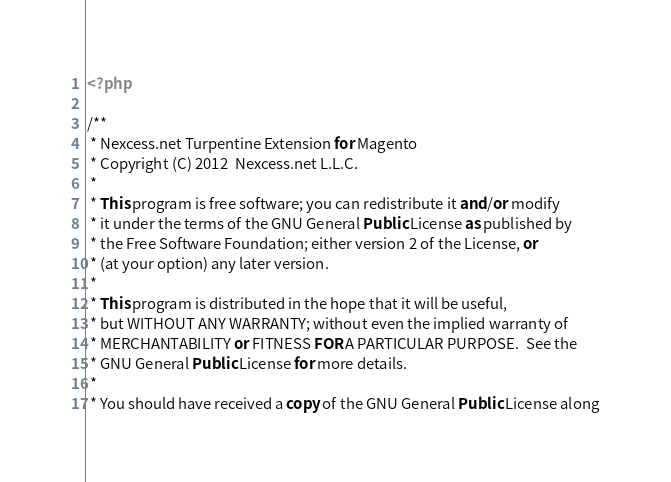<code> <loc_0><loc_0><loc_500><loc_500><_PHP_><?php

/**
 * Nexcess.net Turpentine Extension for Magento
 * Copyright (C) 2012  Nexcess.net L.L.C.
 *
 * This program is free software; you can redistribute it and/or modify
 * it under the terms of the GNU General Public License as published by
 * the Free Software Foundation; either version 2 of the License, or
 * (at your option) any later version.
 *
 * This program is distributed in the hope that it will be useful,
 * but WITHOUT ANY WARRANTY; without even the implied warranty of
 * MERCHANTABILITY or FITNESS FOR A PARTICULAR PURPOSE.  See the
 * GNU General Public License for more details.
 *
 * You should have received a copy of the GNU General Public License along</code> 